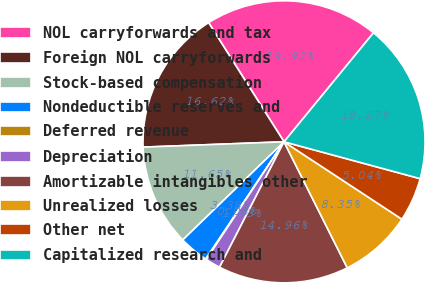<chart> <loc_0><loc_0><loc_500><loc_500><pie_chart><fcel>NOL carryforwards and tax<fcel>Foreign NOL carryforwards<fcel>Stock-based compensation<fcel>Nondeductible reserves and<fcel>Deferred revenue<fcel>Depreciation<fcel>Amortizable intangibles other<fcel>Unrealized losses<fcel>Other net<fcel>Capitalized research and<nl><fcel>19.92%<fcel>16.62%<fcel>11.65%<fcel>3.38%<fcel>0.08%<fcel>1.73%<fcel>14.96%<fcel>8.35%<fcel>5.04%<fcel>18.27%<nl></chart> 